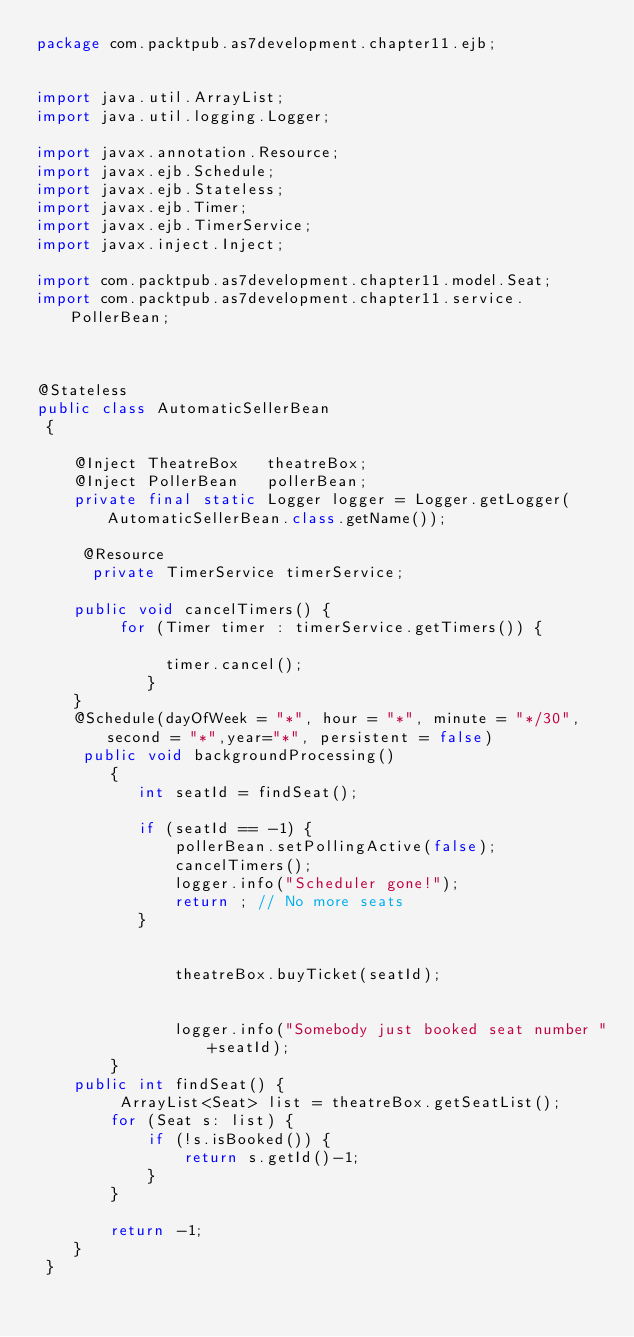Convert code to text. <code><loc_0><loc_0><loc_500><loc_500><_Java_>package com.packtpub.as7development.chapter11.ejb;

 
import java.util.ArrayList;
import java.util.logging.Logger;

import javax.annotation.Resource;
import javax.ejb.Schedule;
import javax.ejb.Stateless;
import javax.ejb.Timer;
import javax.ejb.TimerService;
import javax.inject.Inject;

import com.packtpub.as7development.chapter11.model.Seat;
import com.packtpub.as7development.chapter11.service.PollerBean;
 
 

@Stateless
public class AutomaticSellerBean
 {
	 
	@Inject TheatreBox   theatreBox;
	@Inject PollerBean   pollerBean; 
	private final static Logger logger = Logger.getLogger(AutomaticSellerBean.class.getName()); 
	
	 @Resource
	  private TimerService timerService;
	 
	public void cancelTimers() {
		 for (Timer timer : timerService.getTimers()) {
		       
		      timer.cancel();
		    }
	}
    @Schedule(dayOfWeek = "*", hour = "*", minute = "*/30", second = "*",year="*", persistent = false)
     public void backgroundProcessing()
	    {
     	   int seatId = findSeat();
     	  
    	   if (seatId == -1) {
    		   pollerBean.setPollingActive(false);
    		   cancelTimers();
    		   logger.info("Scheduler gone!"); 
    		   return ; // No more seats
    	   }
    	   
    	   
    		   theatreBox.buyTicket(seatId);
	 		 
		   
    	       logger.info("Somebody just booked seat number "+seatId); 
	    }
    public int findSeat() {
    	 ArrayList<Seat> list = theatreBox.getSeatList();
    	for (Seat s: list) {
    		if (!s.isBooked()) {
    			return s.getId()-1;
    		}
    	}
    	 
    	return -1;
    } 
 }
</code> 